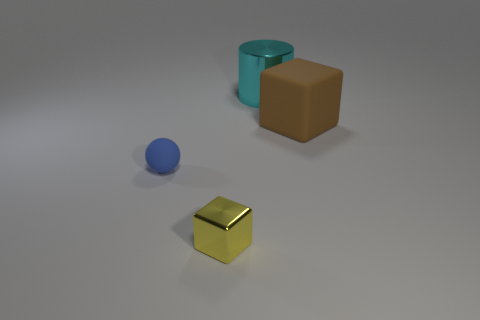What size is the thing that is made of the same material as the blue sphere?
Provide a succinct answer. Large. Is the number of brown cubes behind the tiny blue rubber object greater than the number of big cylinders left of the small yellow cube?
Offer a terse response. Yes. What is the shape of the large cyan object that is made of the same material as the tiny yellow thing?
Give a very brief answer. Cylinder. How many other things are the same shape as the big metal object?
Keep it short and to the point. 0. There is a rubber object that is in front of the large brown block; what shape is it?
Your answer should be very brief. Sphere. The ball is what color?
Your answer should be very brief. Blue. What number of other things are the same size as the brown matte thing?
Your response must be concise. 1. There is a large cyan cylinder that is behind the small object on the right side of the blue matte ball; what is its material?
Ensure brevity in your answer.  Metal. There is a metallic block; is it the same size as the matte object that is left of the small yellow object?
Offer a very short reply. Yes. How many big things are either yellow metal blocks or cyan shiny cylinders?
Ensure brevity in your answer.  1. 